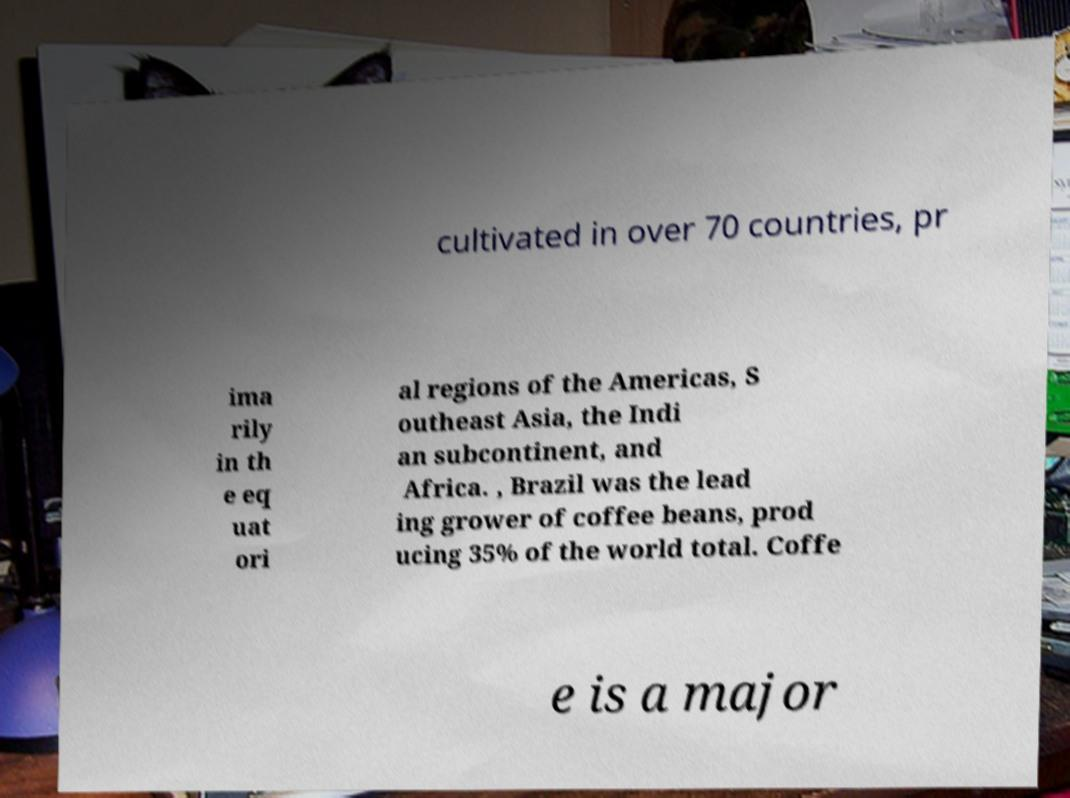Can you read and provide the text displayed in the image?This photo seems to have some interesting text. Can you extract and type it out for me? cultivated in over 70 countries, pr ima rily in th e eq uat ori al regions of the Americas, S outheast Asia, the Indi an subcontinent, and Africa. , Brazil was the lead ing grower of coffee beans, prod ucing 35% of the world total. Coffe e is a major 